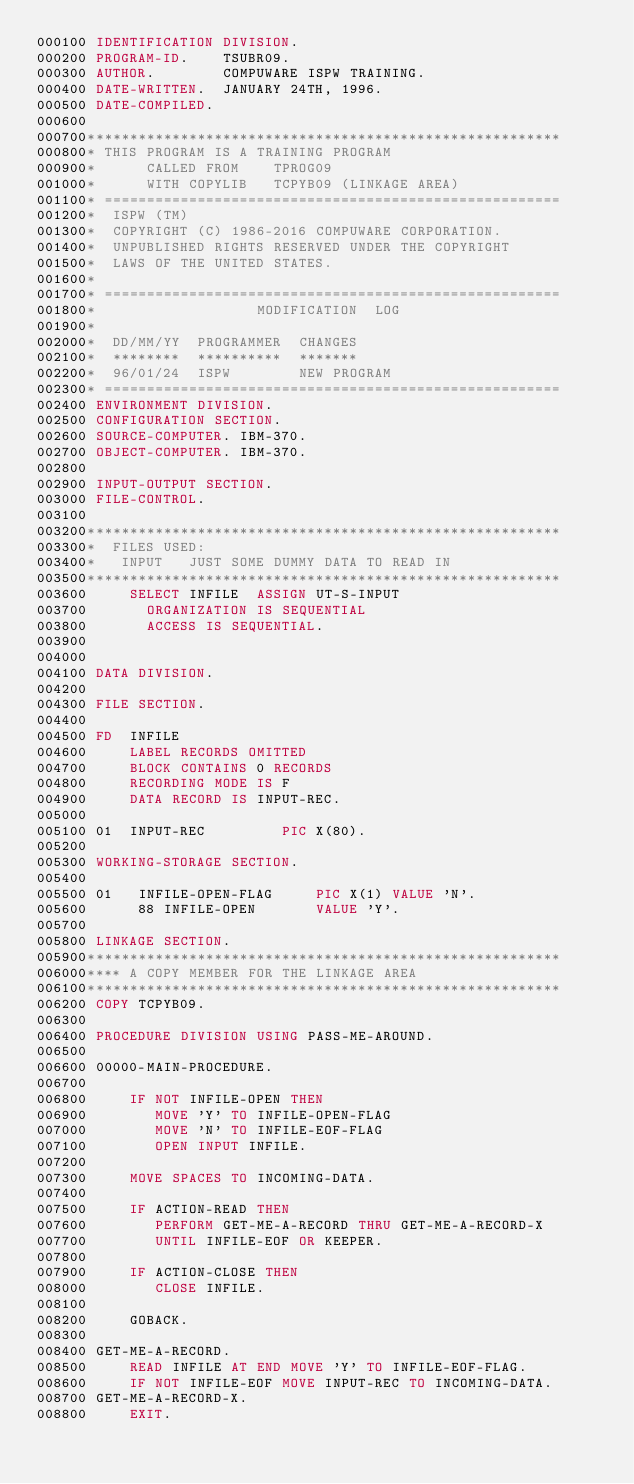<code> <loc_0><loc_0><loc_500><loc_500><_COBOL_>000100 IDENTIFICATION DIVISION.
000200 PROGRAM-ID.    TSUBR09.
000300 AUTHOR.        COMPUWARE ISPW TRAINING.
000400 DATE-WRITTEN.  JANUARY 24TH, 1996.
000500 DATE-COMPILED.
000600
000700********************************************************
000800* THIS PROGRAM IS A TRAINING PROGRAM
000900*      CALLED FROM    TPROG09
001000*      WITH COPYLIB   TCPYB09 (LINKAGE AREA)
001100* ======================================================
001200*  ISPW (TM)
001300*  COPYRIGHT (C) 1986-2016 COMPUWARE CORPORATION.
001400*  UNPUBLISHED RIGHTS RESERVED UNDER THE COPYRIGHT
001500*  LAWS OF THE UNITED STATES.
001600*
001700* ======================================================
001800*                   MODIFICATION  LOG
001900*
002000*  DD/MM/YY  PROGRAMMER  CHANGES
002100*  ********  **********  *******
002200*  96/01/24  ISPW        NEW PROGRAM
002300* ======================================================
002400 ENVIRONMENT DIVISION.
002500 CONFIGURATION SECTION.
002600 SOURCE-COMPUTER. IBM-370.
002700 OBJECT-COMPUTER. IBM-370.
002800
002900 INPUT-OUTPUT SECTION.
003000 FILE-CONTROL.
003100
003200********************************************************
003300*  FILES USED:
003400*   INPUT   JUST SOME DUMMY DATA TO READ IN
003500********************************************************
003600     SELECT INFILE  ASSIGN UT-S-INPUT
003700       ORGANIZATION IS SEQUENTIAL
003800       ACCESS IS SEQUENTIAL.
003900
004000
004100 DATA DIVISION.
004200
004300 FILE SECTION.
004400
004500 FD  INFILE
004600     LABEL RECORDS OMITTED
004700     BLOCK CONTAINS 0 RECORDS
004800     RECORDING MODE IS F
004900     DATA RECORD IS INPUT-REC.
005000
005100 01  INPUT-REC         PIC X(80).
005200
005300 WORKING-STORAGE SECTION.
005400
005500 01   INFILE-OPEN-FLAG     PIC X(1) VALUE 'N'.
005600      88 INFILE-OPEN       VALUE 'Y'.
005700
005800 LINKAGE SECTION.
005900********************************************************
006000**** A COPY MEMBER FOR THE LINKAGE AREA
006100********************************************************
006200 COPY TCPYB09.
006300
006400 PROCEDURE DIVISION USING PASS-ME-AROUND.
006500
006600 00000-MAIN-PROCEDURE.
006700
006800     IF NOT INFILE-OPEN THEN
006900        MOVE 'Y' TO INFILE-OPEN-FLAG
007000        MOVE 'N' TO INFILE-EOF-FLAG
007100        OPEN INPUT INFILE.
007200
007300     MOVE SPACES TO INCOMING-DATA.
007400
007500     IF ACTION-READ THEN
007600        PERFORM GET-ME-A-RECORD THRU GET-ME-A-RECORD-X
007700        UNTIL INFILE-EOF OR KEEPER.
007800
007900     IF ACTION-CLOSE THEN
008000        CLOSE INFILE.
008100
008200     GOBACK.
008300
008400 GET-ME-A-RECORD.
008500     READ INFILE AT END MOVE 'Y' TO INFILE-EOF-FLAG.
008600     IF NOT INFILE-EOF MOVE INPUT-REC TO INCOMING-DATA.
008700 GET-ME-A-RECORD-X.
008800     EXIT.</code> 